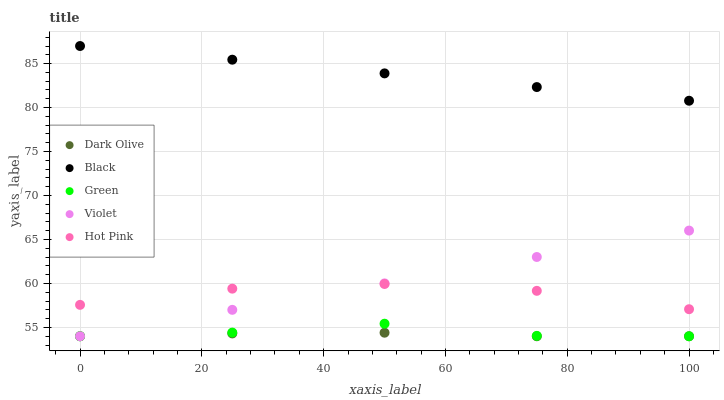Does Dark Olive have the minimum area under the curve?
Answer yes or no. Yes. Does Black have the maximum area under the curve?
Answer yes or no. Yes. Does Hot Pink have the minimum area under the curve?
Answer yes or no. No. Does Hot Pink have the maximum area under the curve?
Answer yes or no. No. Is Black the smoothest?
Answer yes or no. Yes. Is Green the roughest?
Answer yes or no. Yes. Is Hot Pink the smoothest?
Answer yes or no. No. Is Hot Pink the roughest?
Answer yes or no. No. Does Green have the lowest value?
Answer yes or no. Yes. Does Hot Pink have the lowest value?
Answer yes or no. No. Does Black have the highest value?
Answer yes or no. Yes. Does Hot Pink have the highest value?
Answer yes or no. No. Is Green less than Hot Pink?
Answer yes or no. Yes. Is Black greater than Green?
Answer yes or no. Yes. Does Dark Olive intersect Violet?
Answer yes or no. Yes. Is Dark Olive less than Violet?
Answer yes or no. No. Is Dark Olive greater than Violet?
Answer yes or no. No. Does Green intersect Hot Pink?
Answer yes or no. No. 